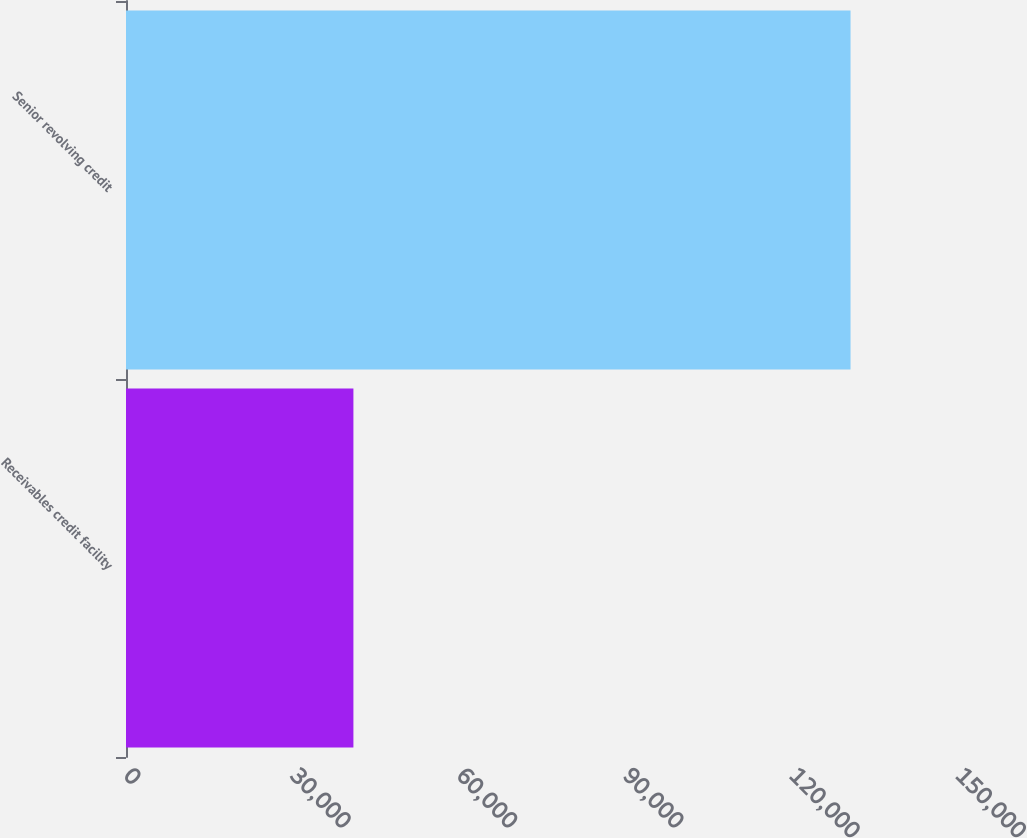<chart> <loc_0><loc_0><loc_500><loc_500><bar_chart><fcel>Receivables credit facility<fcel>Senior revolving credit<nl><fcel>41000<fcel>130627<nl></chart> 